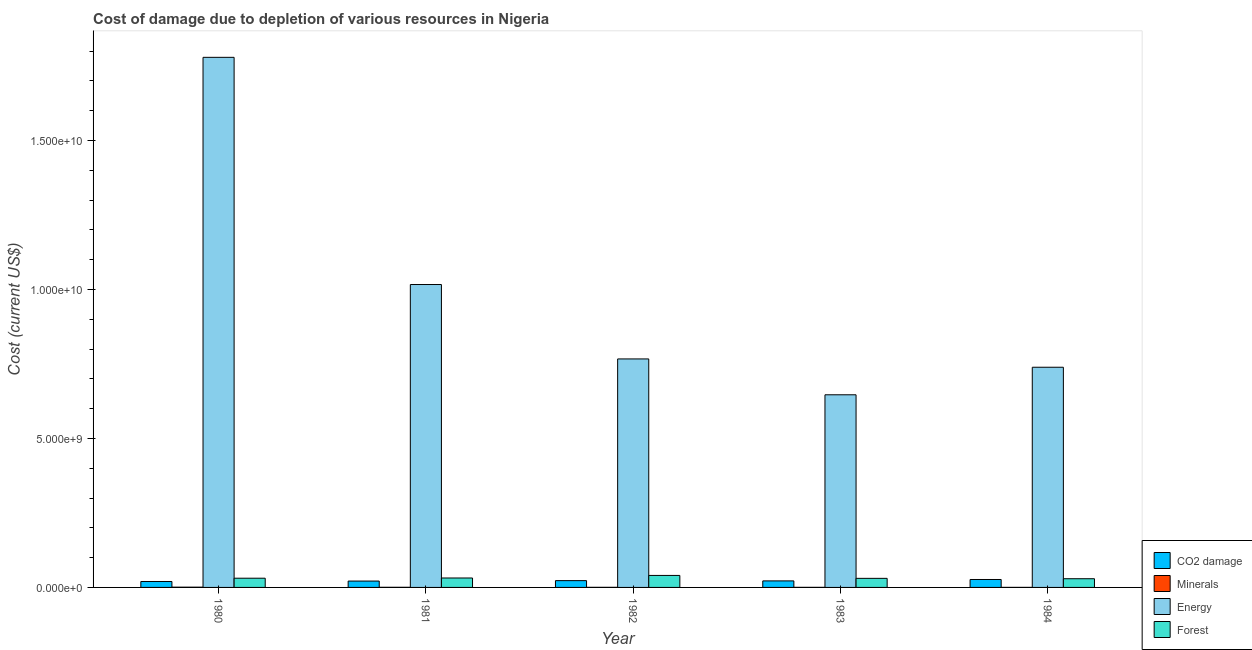Are the number of bars per tick equal to the number of legend labels?
Provide a succinct answer. Yes. How many bars are there on the 1st tick from the left?
Keep it short and to the point. 4. How many bars are there on the 5th tick from the right?
Give a very brief answer. 4. In how many cases, is the number of bars for a given year not equal to the number of legend labels?
Provide a succinct answer. 0. What is the cost of damage due to depletion of forests in 1980?
Offer a very short reply. 3.09e+08. Across all years, what is the maximum cost of damage due to depletion of energy?
Make the answer very short. 1.78e+1. Across all years, what is the minimum cost of damage due to depletion of coal?
Provide a short and direct response. 1.99e+08. What is the total cost of damage due to depletion of minerals in the graph?
Your answer should be compact. 2.00e+07. What is the difference between the cost of damage due to depletion of energy in 1981 and that in 1983?
Keep it short and to the point. 3.70e+09. What is the difference between the cost of damage due to depletion of forests in 1983 and the cost of damage due to depletion of energy in 1980?
Ensure brevity in your answer.  -4.64e+06. What is the average cost of damage due to depletion of forests per year?
Ensure brevity in your answer.  3.25e+08. In how many years, is the cost of damage due to depletion of forests greater than 10000000000 US$?
Ensure brevity in your answer.  0. What is the ratio of the cost of damage due to depletion of forests in 1981 to that in 1984?
Offer a very short reply. 1.08. Is the difference between the cost of damage due to depletion of energy in 1981 and 1983 greater than the difference between the cost of damage due to depletion of forests in 1981 and 1983?
Make the answer very short. No. What is the difference between the highest and the second highest cost of damage due to depletion of coal?
Provide a succinct answer. 3.86e+07. What is the difference between the highest and the lowest cost of damage due to depletion of forests?
Your answer should be compact. 1.11e+08. Is the sum of the cost of damage due to depletion of minerals in 1983 and 1984 greater than the maximum cost of damage due to depletion of forests across all years?
Your response must be concise. No. Is it the case that in every year, the sum of the cost of damage due to depletion of forests and cost of damage due to depletion of minerals is greater than the sum of cost of damage due to depletion of coal and cost of damage due to depletion of energy?
Provide a short and direct response. No. What does the 3rd bar from the left in 1983 represents?
Provide a succinct answer. Energy. What does the 1st bar from the right in 1984 represents?
Make the answer very short. Forest. Is it the case that in every year, the sum of the cost of damage due to depletion of coal and cost of damage due to depletion of minerals is greater than the cost of damage due to depletion of energy?
Keep it short and to the point. No. Are all the bars in the graph horizontal?
Offer a very short reply. No. Are the values on the major ticks of Y-axis written in scientific E-notation?
Provide a short and direct response. Yes. Does the graph contain grids?
Make the answer very short. No. How many legend labels are there?
Provide a short and direct response. 4. How are the legend labels stacked?
Provide a succinct answer. Vertical. What is the title of the graph?
Offer a terse response. Cost of damage due to depletion of various resources in Nigeria . What is the label or title of the Y-axis?
Your response must be concise. Cost (current US$). What is the Cost (current US$) in CO2 damage in 1980?
Ensure brevity in your answer.  1.99e+08. What is the Cost (current US$) of Minerals in 1980?
Your response must be concise. 8.49e+06. What is the Cost (current US$) in Energy in 1980?
Offer a very short reply. 1.78e+1. What is the Cost (current US$) in Forest in 1980?
Your answer should be very brief. 3.09e+08. What is the Cost (current US$) in CO2 damage in 1981?
Offer a terse response. 2.13e+08. What is the Cost (current US$) in Minerals in 1981?
Keep it short and to the point. 4.22e+06. What is the Cost (current US$) in Energy in 1981?
Ensure brevity in your answer.  1.02e+1. What is the Cost (current US$) in Forest in 1981?
Offer a very short reply. 3.17e+08. What is the Cost (current US$) in CO2 damage in 1982?
Ensure brevity in your answer.  2.28e+08. What is the Cost (current US$) in Minerals in 1982?
Your response must be concise. 3.01e+06. What is the Cost (current US$) in Energy in 1982?
Your response must be concise. 7.67e+09. What is the Cost (current US$) of Forest in 1982?
Offer a terse response. 4.03e+08. What is the Cost (current US$) of CO2 damage in 1983?
Keep it short and to the point. 2.19e+08. What is the Cost (current US$) of Minerals in 1983?
Your answer should be very brief. 2.75e+06. What is the Cost (current US$) in Energy in 1983?
Your answer should be very brief. 6.46e+09. What is the Cost (current US$) in Forest in 1983?
Provide a short and direct response. 3.04e+08. What is the Cost (current US$) of CO2 damage in 1984?
Provide a succinct answer. 2.66e+08. What is the Cost (current US$) in Minerals in 1984?
Keep it short and to the point. 1.48e+06. What is the Cost (current US$) of Energy in 1984?
Your answer should be very brief. 7.39e+09. What is the Cost (current US$) of Forest in 1984?
Your response must be concise. 2.92e+08. Across all years, what is the maximum Cost (current US$) in CO2 damage?
Keep it short and to the point. 2.66e+08. Across all years, what is the maximum Cost (current US$) of Minerals?
Make the answer very short. 8.49e+06. Across all years, what is the maximum Cost (current US$) in Energy?
Provide a succinct answer. 1.78e+1. Across all years, what is the maximum Cost (current US$) of Forest?
Keep it short and to the point. 4.03e+08. Across all years, what is the minimum Cost (current US$) of CO2 damage?
Offer a very short reply. 1.99e+08. Across all years, what is the minimum Cost (current US$) in Minerals?
Your response must be concise. 1.48e+06. Across all years, what is the minimum Cost (current US$) of Energy?
Offer a terse response. 6.46e+09. Across all years, what is the minimum Cost (current US$) of Forest?
Offer a very short reply. 2.92e+08. What is the total Cost (current US$) in CO2 damage in the graph?
Offer a terse response. 1.13e+09. What is the total Cost (current US$) of Minerals in the graph?
Ensure brevity in your answer.  2.00e+07. What is the total Cost (current US$) of Energy in the graph?
Keep it short and to the point. 4.95e+1. What is the total Cost (current US$) of Forest in the graph?
Your response must be concise. 1.62e+09. What is the difference between the Cost (current US$) of CO2 damage in 1980 and that in 1981?
Provide a succinct answer. -1.41e+07. What is the difference between the Cost (current US$) of Minerals in 1980 and that in 1981?
Your response must be concise. 4.27e+06. What is the difference between the Cost (current US$) of Energy in 1980 and that in 1981?
Ensure brevity in your answer.  7.62e+09. What is the difference between the Cost (current US$) of Forest in 1980 and that in 1981?
Give a very brief answer. -7.56e+06. What is the difference between the Cost (current US$) in CO2 damage in 1980 and that in 1982?
Your response must be concise. -2.87e+07. What is the difference between the Cost (current US$) of Minerals in 1980 and that in 1982?
Your response must be concise. 5.48e+06. What is the difference between the Cost (current US$) of Energy in 1980 and that in 1982?
Give a very brief answer. 1.01e+1. What is the difference between the Cost (current US$) of Forest in 1980 and that in 1982?
Your response must be concise. -9.37e+07. What is the difference between the Cost (current US$) in CO2 damage in 1980 and that in 1983?
Give a very brief answer. -1.98e+07. What is the difference between the Cost (current US$) in Minerals in 1980 and that in 1983?
Ensure brevity in your answer.  5.74e+06. What is the difference between the Cost (current US$) in Energy in 1980 and that in 1983?
Provide a succinct answer. 1.13e+1. What is the difference between the Cost (current US$) of Forest in 1980 and that in 1983?
Make the answer very short. 4.64e+06. What is the difference between the Cost (current US$) of CO2 damage in 1980 and that in 1984?
Give a very brief answer. -6.73e+07. What is the difference between the Cost (current US$) in Minerals in 1980 and that in 1984?
Offer a terse response. 7.01e+06. What is the difference between the Cost (current US$) in Energy in 1980 and that in 1984?
Ensure brevity in your answer.  1.04e+1. What is the difference between the Cost (current US$) in Forest in 1980 and that in 1984?
Give a very brief answer. 1.72e+07. What is the difference between the Cost (current US$) in CO2 damage in 1981 and that in 1982?
Make the answer very short. -1.47e+07. What is the difference between the Cost (current US$) of Minerals in 1981 and that in 1982?
Your response must be concise. 1.21e+06. What is the difference between the Cost (current US$) of Energy in 1981 and that in 1982?
Ensure brevity in your answer.  2.50e+09. What is the difference between the Cost (current US$) of Forest in 1981 and that in 1982?
Your answer should be compact. -8.61e+07. What is the difference between the Cost (current US$) in CO2 damage in 1981 and that in 1983?
Provide a short and direct response. -5.71e+06. What is the difference between the Cost (current US$) in Minerals in 1981 and that in 1983?
Provide a succinct answer. 1.47e+06. What is the difference between the Cost (current US$) of Energy in 1981 and that in 1983?
Ensure brevity in your answer.  3.70e+09. What is the difference between the Cost (current US$) of Forest in 1981 and that in 1983?
Provide a short and direct response. 1.22e+07. What is the difference between the Cost (current US$) in CO2 damage in 1981 and that in 1984?
Your answer should be very brief. -5.32e+07. What is the difference between the Cost (current US$) of Minerals in 1981 and that in 1984?
Make the answer very short. 2.74e+06. What is the difference between the Cost (current US$) of Energy in 1981 and that in 1984?
Your answer should be compact. 2.78e+09. What is the difference between the Cost (current US$) in Forest in 1981 and that in 1984?
Give a very brief answer. 2.48e+07. What is the difference between the Cost (current US$) in CO2 damage in 1982 and that in 1983?
Offer a very short reply. 8.94e+06. What is the difference between the Cost (current US$) in Minerals in 1982 and that in 1983?
Your answer should be very brief. 2.58e+05. What is the difference between the Cost (current US$) in Energy in 1982 and that in 1983?
Your answer should be very brief. 1.20e+09. What is the difference between the Cost (current US$) in Forest in 1982 and that in 1983?
Your answer should be very brief. 9.83e+07. What is the difference between the Cost (current US$) of CO2 damage in 1982 and that in 1984?
Your answer should be compact. -3.86e+07. What is the difference between the Cost (current US$) in Minerals in 1982 and that in 1984?
Ensure brevity in your answer.  1.52e+06. What is the difference between the Cost (current US$) of Energy in 1982 and that in 1984?
Your answer should be very brief. 2.79e+08. What is the difference between the Cost (current US$) in Forest in 1982 and that in 1984?
Your answer should be compact. 1.11e+08. What is the difference between the Cost (current US$) in CO2 damage in 1983 and that in 1984?
Your answer should be compact. -4.75e+07. What is the difference between the Cost (current US$) in Minerals in 1983 and that in 1984?
Keep it short and to the point. 1.27e+06. What is the difference between the Cost (current US$) of Energy in 1983 and that in 1984?
Your answer should be very brief. -9.25e+08. What is the difference between the Cost (current US$) in Forest in 1983 and that in 1984?
Make the answer very short. 1.26e+07. What is the difference between the Cost (current US$) of CO2 damage in 1980 and the Cost (current US$) of Minerals in 1981?
Your answer should be very brief. 1.95e+08. What is the difference between the Cost (current US$) in CO2 damage in 1980 and the Cost (current US$) in Energy in 1981?
Give a very brief answer. -9.97e+09. What is the difference between the Cost (current US$) of CO2 damage in 1980 and the Cost (current US$) of Forest in 1981?
Your answer should be compact. -1.18e+08. What is the difference between the Cost (current US$) in Minerals in 1980 and the Cost (current US$) in Energy in 1981?
Give a very brief answer. -1.02e+1. What is the difference between the Cost (current US$) of Minerals in 1980 and the Cost (current US$) of Forest in 1981?
Offer a terse response. -3.08e+08. What is the difference between the Cost (current US$) of Energy in 1980 and the Cost (current US$) of Forest in 1981?
Provide a succinct answer. 1.75e+1. What is the difference between the Cost (current US$) of CO2 damage in 1980 and the Cost (current US$) of Minerals in 1982?
Provide a succinct answer. 1.96e+08. What is the difference between the Cost (current US$) in CO2 damage in 1980 and the Cost (current US$) in Energy in 1982?
Offer a terse response. -7.47e+09. What is the difference between the Cost (current US$) of CO2 damage in 1980 and the Cost (current US$) of Forest in 1982?
Offer a terse response. -2.04e+08. What is the difference between the Cost (current US$) in Minerals in 1980 and the Cost (current US$) in Energy in 1982?
Make the answer very short. -7.66e+09. What is the difference between the Cost (current US$) of Minerals in 1980 and the Cost (current US$) of Forest in 1982?
Make the answer very short. -3.94e+08. What is the difference between the Cost (current US$) of Energy in 1980 and the Cost (current US$) of Forest in 1982?
Ensure brevity in your answer.  1.74e+1. What is the difference between the Cost (current US$) in CO2 damage in 1980 and the Cost (current US$) in Minerals in 1983?
Offer a terse response. 1.96e+08. What is the difference between the Cost (current US$) of CO2 damage in 1980 and the Cost (current US$) of Energy in 1983?
Provide a succinct answer. -6.26e+09. What is the difference between the Cost (current US$) in CO2 damage in 1980 and the Cost (current US$) in Forest in 1983?
Ensure brevity in your answer.  -1.05e+08. What is the difference between the Cost (current US$) of Minerals in 1980 and the Cost (current US$) of Energy in 1983?
Keep it short and to the point. -6.46e+09. What is the difference between the Cost (current US$) in Minerals in 1980 and the Cost (current US$) in Forest in 1983?
Keep it short and to the point. -2.96e+08. What is the difference between the Cost (current US$) in Energy in 1980 and the Cost (current US$) in Forest in 1983?
Your answer should be compact. 1.75e+1. What is the difference between the Cost (current US$) in CO2 damage in 1980 and the Cost (current US$) in Minerals in 1984?
Offer a terse response. 1.98e+08. What is the difference between the Cost (current US$) of CO2 damage in 1980 and the Cost (current US$) of Energy in 1984?
Provide a short and direct response. -7.19e+09. What is the difference between the Cost (current US$) of CO2 damage in 1980 and the Cost (current US$) of Forest in 1984?
Offer a terse response. -9.27e+07. What is the difference between the Cost (current US$) of Minerals in 1980 and the Cost (current US$) of Energy in 1984?
Your response must be concise. -7.38e+09. What is the difference between the Cost (current US$) of Minerals in 1980 and the Cost (current US$) of Forest in 1984?
Offer a very short reply. -2.83e+08. What is the difference between the Cost (current US$) of Energy in 1980 and the Cost (current US$) of Forest in 1984?
Your answer should be compact. 1.75e+1. What is the difference between the Cost (current US$) of CO2 damage in 1981 and the Cost (current US$) of Minerals in 1982?
Make the answer very short. 2.10e+08. What is the difference between the Cost (current US$) in CO2 damage in 1981 and the Cost (current US$) in Energy in 1982?
Offer a terse response. -7.45e+09. What is the difference between the Cost (current US$) in CO2 damage in 1981 and the Cost (current US$) in Forest in 1982?
Your response must be concise. -1.90e+08. What is the difference between the Cost (current US$) of Minerals in 1981 and the Cost (current US$) of Energy in 1982?
Offer a very short reply. -7.66e+09. What is the difference between the Cost (current US$) in Minerals in 1981 and the Cost (current US$) in Forest in 1982?
Ensure brevity in your answer.  -3.99e+08. What is the difference between the Cost (current US$) of Energy in 1981 and the Cost (current US$) of Forest in 1982?
Provide a succinct answer. 9.76e+09. What is the difference between the Cost (current US$) of CO2 damage in 1981 and the Cost (current US$) of Minerals in 1983?
Make the answer very short. 2.10e+08. What is the difference between the Cost (current US$) of CO2 damage in 1981 and the Cost (current US$) of Energy in 1983?
Your answer should be very brief. -6.25e+09. What is the difference between the Cost (current US$) in CO2 damage in 1981 and the Cost (current US$) in Forest in 1983?
Make the answer very short. -9.13e+07. What is the difference between the Cost (current US$) of Minerals in 1981 and the Cost (current US$) of Energy in 1983?
Offer a terse response. -6.46e+09. What is the difference between the Cost (current US$) of Minerals in 1981 and the Cost (current US$) of Forest in 1983?
Your answer should be compact. -3.00e+08. What is the difference between the Cost (current US$) in Energy in 1981 and the Cost (current US$) in Forest in 1983?
Your response must be concise. 9.86e+09. What is the difference between the Cost (current US$) in CO2 damage in 1981 and the Cost (current US$) in Minerals in 1984?
Keep it short and to the point. 2.12e+08. What is the difference between the Cost (current US$) of CO2 damage in 1981 and the Cost (current US$) of Energy in 1984?
Provide a short and direct response. -7.18e+09. What is the difference between the Cost (current US$) of CO2 damage in 1981 and the Cost (current US$) of Forest in 1984?
Your answer should be very brief. -7.87e+07. What is the difference between the Cost (current US$) of Minerals in 1981 and the Cost (current US$) of Energy in 1984?
Offer a terse response. -7.38e+09. What is the difference between the Cost (current US$) in Minerals in 1981 and the Cost (current US$) in Forest in 1984?
Make the answer very short. -2.88e+08. What is the difference between the Cost (current US$) of Energy in 1981 and the Cost (current US$) of Forest in 1984?
Offer a very short reply. 9.87e+09. What is the difference between the Cost (current US$) in CO2 damage in 1982 and the Cost (current US$) in Minerals in 1983?
Offer a very short reply. 2.25e+08. What is the difference between the Cost (current US$) in CO2 damage in 1982 and the Cost (current US$) in Energy in 1983?
Your response must be concise. -6.24e+09. What is the difference between the Cost (current US$) of CO2 damage in 1982 and the Cost (current US$) of Forest in 1983?
Give a very brief answer. -7.66e+07. What is the difference between the Cost (current US$) of Minerals in 1982 and the Cost (current US$) of Energy in 1983?
Offer a very short reply. -6.46e+09. What is the difference between the Cost (current US$) in Minerals in 1982 and the Cost (current US$) in Forest in 1983?
Your answer should be compact. -3.01e+08. What is the difference between the Cost (current US$) in Energy in 1982 and the Cost (current US$) in Forest in 1983?
Your response must be concise. 7.36e+09. What is the difference between the Cost (current US$) of CO2 damage in 1982 and the Cost (current US$) of Minerals in 1984?
Your answer should be compact. 2.26e+08. What is the difference between the Cost (current US$) in CO2 damage in 1982 and the Cost (current US$) in Energy in 1984?
Your answer should be very brief. -7.16e+09. What is the difference between the Cost (current US$) in CO2 damage in 1982 and the Cost (current US$) in Forest in 1984?
Make the answer very short. -6.40e+07. What is the difference between the Cost (current US$) in Minerals in 1982 and the Cost (current US$) in Energy in 1984?
Ensure brevity in your answer.  -7.39e+09. What is the difference between the Cost (current US$) of Minerals in 1982 and the Cost (current US$) of Forest in 1984?
Ensure brevity in your answer.  -2.89e+08. What is the difference between the Cost (current US$) of Energy in 1982 and the Cost (current US$) of Forest in 1984?
Offer a terse response. 7.38e+09. What is the difference between the Cost (current US$) of CO2 damage in 1983 and the Cost (current US$) of Minerals in 1984?
Provide a succinct answer. 2.17e+08. What is the difference between the Cost (current US$) of CO2 damage in 1983 and the Cost (current US$) of Energy in 1984?
Give a very brief answer. -7.17e+09. What is the difference between the Cost (current US$) in CO2 damage in 1983 and the Cost (current US$) in Forest in 1984?
Offer a terse response. -7.30e+07. What is the difference between the Cost (current US$) of Minerals in 1983 and the Cost (current US$) of Energy in 1984?
Give a very brief answer. -7.39e+09. What is the difference between the Cost (current US$) of Minerals in 1983 and the Cost (current US$) of Forest in 1984?
Your answer should be very brief. -2.89e+08. What is the difference between the Cost (current US$) of Energy in 1983 and the Cost (current US$) of Forest in 1984?
Offer a very short reply. 6.17e+09. What is the average Cost (current US$) of CO2 damage per year?
Your response must be concise. 2.25e+08. What is the average Cost (current US$) in Minerals per year?
Provide a short and direct response. 3.99e+06. What is the average Cost (current US$) of Energy per year?
Your answer should be very brief. 9.89e+09. What is the average Cost (current US$) of Forest per year?
Offer a very short reply. 3.25e+08. In the year 1980, what is the difference between the Cost (current US$) of CO2 damage and Cost (current US$) of Minerals?
Provide a succinct answer. 1.91e+08. In the year 1980, what is the difference between the Cost (current US$) of CO2 damage and Cost (current US$) of Energy?
Your answer should be compact. -1.76e+1. In the year 1980, what is the difference between the Cost (current US$) of CO2 damage and Cost (current US$) of Forest?
Give a very brief answer. -1.10e+08. In the year 1980, what is the difference between the Cost (current US$) of Minerals and Cost (current US$) of Energy?
Your answer should be compact. -1.78e+1. In the year 1980, what is the difference between the Cost (current US$) of Minerals and Cost (current US$) of Forest?
Your response must be concise. -3.01e+08. In the year 1980, what is the difference between the Cost (current US$) of Energy and Cost (current US$) of Forest?
Offer a terse response. 1.75e+1. In the year 1981, what is the difference between the Cost (current US$) in CO2 damage and Cost (current US$) in Minerals?
Make the answer very short. 2.09e+08. In the year 1981, what is the difference between the Cost (current US$) in CO2 damage and Cost (current US$) in Energy?
Your response must be concise. -9.95e+09. In the year 1981, what is the difference between the Cost (current US$) of CO2 damage and Cost (current US$) of Forest?
Your answer should be very brief. -1.03e+08. In the year 1981, what is the difference between the Cost (current US$) in Minerals and Cost (current US$) in Energy?
Offer a terse response. -1.02e+1. In the year 1981, what is the difference between the Cost (current US$) in Minerals and Cost (current US$) in Forest?
Offer a very short reply. -3.12e+08. In the year 1981, what is the difference between the Cost (current US$) in Energy and Cost (current US$) in Forest?
Provide a short and direct response. 9.85e+09. In the year 1982, what is the difference between the Cost (current US$) of CO2 damage and Cost (current US$) of Minerals?
Give a very brief answer. 2.25e+08. In the year 1982, what is the difference between the Cost (current US$) of CO2 damage and Cost (current US$) of Energy?
Provide a short and direct response. -7.44e+09. In the year 1982, what is the difference between the Cost (current US$) of CO2 damage and Cost (current US$) of Forest?
Your response must be concise. -1.75e+08. In the year 1982, what is the difference between the Cost (current US$) in Minerals and Cost (current US$) in Energy?
Offer a terse response. -7.66e+09. In the year 1982, what is the difference between the Cost (current US$) of Minerals and Cost (current US$) of Forest?
Make the answer very short. -4.00e+08. In the year 1982, what is the difference between the Cost (current US$) in Energy and Cost (current US$) in Forest?
Offer a very short reply. 7.26e+09. In the year 1983, what is the difference between the Cost (current US$) in CO2 damage and Cost (current US$) in Minerals?
Give a very brief answer. 2.16e+08. In the year 1983, what is the difference between the Cost (current US$) of CO2 damage and Cost (current US$) of Energy?
Offer a very short reply. -6.25e+09. In the year 1983, what is the difference between the Cost (current US$) of CO2 damage and Cost (current US$) of Forest?
Your response must be concise. -8.56e+07. In the year 1983, what is the difference between the Cost (current US$) of Minerals and Cost (current US$) of Energy?
Your response must be concise. -6.46e+09. In the year 1983, what is the difference between the Cost (current US$) of Minerals and Cost (current US$) of Forest?
Your answer should be compact. -3.02e+08. In the year 1983, what is the difference between the Cost (current US$) in Energy and Cost (current US$) in Forest?
Keep it short and to the point. 6.16e+09. In the year 1984, what is the difference between the Cost (current US$) in CO2 damage and Cost (current US$) in Minerals?
Make the answer very short. 2.65e+08. In the year 1984, what is the difference between the Cost (current US$) of CO2 damage and Cost (current US$) of Energy?
Your answer should be very brief. -7.12e+09. In the year 1984, what is the difference between the Cost (current US$) of CO2 damage and Cost (current US$) of Forest?
Make the answer very short. -2.55e+07. In the year 1984, what is the difference between the Cost (current US$) in Minerals and Cost (current US$) in Energy?
Offer a very short reply. -7.39e+09. In the year 1984, what is the difference between the Cost (current US$) of Minerals and Cost (current US$) of Forest?
Provide a short and direct response. -2.90e+08. In the year 1984, what is the difference between the Cost (current US$) of Energy and Cost (current US$) of Forest?
Make the answer very short. 7.10e+09. What is the ratio of the Cost (current US$) in CO2 damage in 1980 to that in 1981?
Your answer should be very brief. 0.93. What is the ratio of the Cost (current US$) of Minerals in 1980 to that in 1981?
Provide a succinct answer. 2.01. What is the ratio of the Cost (current US$) of Energy in 1980 to that in 1981?
Offer a terse response. 1.75. What is the ratio of the Cost (current US$) in Forest in 1980 to that in 1981?
Provide a succinct answer. 0.98. What is the ratio of the Cost (current US$) of CO2 damage in 1980 to that in 1982?
Your answer should be very brief. 0.87. What is the ratio of the Cost (current US$) of Minerals in 1980 to that in 1982?
Give a very brief answer. 2.82. What is the ratio of the Cost (current US$) of Energy in 1980 to that in 1982?
Offer a terse response. 2.32. What is the ratio of the Cost (current US$) in Forest in 1980 to that in 1982?
Offer a terse response. 0.77. What is the ratio of the Cost (current US$) of CO2 damage in 1980 to that in 1983?
Your response must be concise. 0.91. What is the ratio of the Cost (current US$) in Minerals in 1980 to that in 1983?
Provide a short and direct response. 3.09. What is the ratio of the Cost (current US$) of Energy in 1980 to that in 1983?
Keep it short and to the point. 2.75. What is the ratio of the Cost (current US$) in Forest in 1980 to that in 1983?
Your response must be concise. 1.02. What is the ratio of the Cost (current US$) of CO2 damage in 1980 to that in 1984?
Provide a succinct answer. 0.75. What is the ratio of the Cost (current US$) of Minerals in 1980 to that in 1984?
Ensure brevity in your answer.  5.72. What is the ratio of the Cost (current US$) of Energy in 1980 to that in 1984?
Offer a very short reply. 2.41. What is the ratio of the Cost (current US$) in Forest in 1980 to that in 1984?
Make the answer very short. 1.06. What is the ratio of the Cost (current US$) in CO2 damage in 1981 to that in 1982?
Give a very brief answer. 0.94. What is the ratio of the Cost (current US$) of Minerals in 1981 to that in 1982?
Make the answer very short. 1.4. What is the ratio of the Cost (current US$) of Energy in 1981 to that in 1982?
Provide a short and direct response. 1.33. What is the ratio of the Cost (current US$) of Forest in 1981 to that in 1982?
Keep it short and to the point. 0.79. What is the ratio of the Cost (current US$) in CO2 damage in 1981 to that in 1983?
Offer a terse response. 0.97. What is the ratio of the Cost (current US$) of Minerals in 1981 to that in 1983?
Offer a terse response. 1.53. What is the ratio of the Cost (current US$) of Energy in 1981 to that in 1983?
Offer a terse response. 1.57. What is the ratio of the Cost (current US$) in Forest in 1981 to that in 1983?
Keep it short and to the point. 1.04. What is the ratio of the Cost (current US$) of CO2 damage in 1981 to that in 1984?
Your answer should be very brief. 0.8. What is the ratio of the Cost (current US$) in Minerals in 1981 to that in 1984?
Ensure brevity in your answer.  2.84. What is the ratio of the Cost (current US$) in Energy in 1981 to that in 1984?
Provide a succinct answer. 1.38. What is the ratio of the Cost (current US$) of Forest in 1981 to that in 1984?
Provide a succinct answer. 1.08. What is the ratio of the Cost (current US$) of CO2 damage in 1982 to that in 1983?
Your answer should be very brief. 1.04. What is the ratio of the Cost (current US$) in Minerals in 1982 to that in 1983?
Provide a succinct answer. 1.09. What is the ratio of the Cost (current US$) in Energy in 1982 to that in 1983?
Your answer should be very brief. 1.19. What is the ratio of the Cost (current US$) in Forest in 1982 to that in 1983?
Provide a succinct answer. 1.32. What is the ratio of the Cost (current US$) of CO2 damage in 1982 to that in 1984?
Make the answer very short. 0.86. What is the ratio of the Cost (current US$) of Minerals in 1982 to that in 1984?
Give a very brief answer. 2.03. What is the ratio of the Cost (current US$) of Energy in 1982 to that in 1984?
Make the answer very short. 1.04. What is the ratio of the Cost (current US$) of Forest in 1982 to that in 1984?
Offer a terse response. 1.38. What is the ratio of the Cost (current US$) in CO2 damage in 1983 to that in 1984?
Keep it short and to the point. 0.82. What is the ratio of the Cost (current US$) in Minerals in 1983 to that in 1984?
Give a very brief answer. 1.85. What is the ratio of the Cost (current US$) of Energy in 1983 to that in 1984?
Your answer should be very brief. 0.87. What is the ratio of the Cost (current US$) of Forest in 1983 to that in 1984?
Keep it short and to the point. 1.04. What is the difference between the highest and the second highest Cost (current US$) of CO2 damage?
Give a very brief answer. 3.86e+07. What is the difference between the highest and the second highest Cost (current US$) of Minerals?
Offer a very short reply. 4.27e+06. What is the difference between the highest and the second highest Cost (current US$) of Energy?
Provide a succinct answer. 7.62e+09. What is the difference between the highest and the second highest Cost (current US$) in Forest?
Provide a short and direct response. 8.61e+07. What is the difference between the highest and the lowest Cost (current US$) of CO2 damage?
Ensure brevity in your answer.  6.73e+07. What is the difference between the highest and the lowest Cost (current US$) in Minerals?
Provide a succinct answer. 7.01e+06. What is the difference between the highest and the lowest Cost (current US$) of Energy?
Provide a short and direct response. 1.13e+1. What is the difference between the highest and the lowest Cost (current US$) of Forest?
Keep it short and to the point. 1.11e+08. 